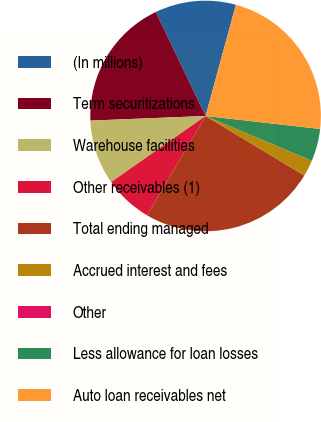Convert chart to OTSL. <chart><loc_0><loc_0><loc_500><loc_500><pie_chart><fcel>(In millions)<fcel>Term securitizations<fcel>Warehouse facilities<fcel>Other receivables (1)<fcel>Total ending managed<fcel>Accrued interest and fees<fcel>Other<fcel>Less allowance for loan losses<fcel>Auto loan receivables net<nl><fcel>11.35%<fcel>18.52%<fcel>9.08%<fcel>6.81%<fcel>24.83%<fcel>2.28%<fcel>0.01%<fcel>4.55%<fcel>22.56%<nl></chart> 